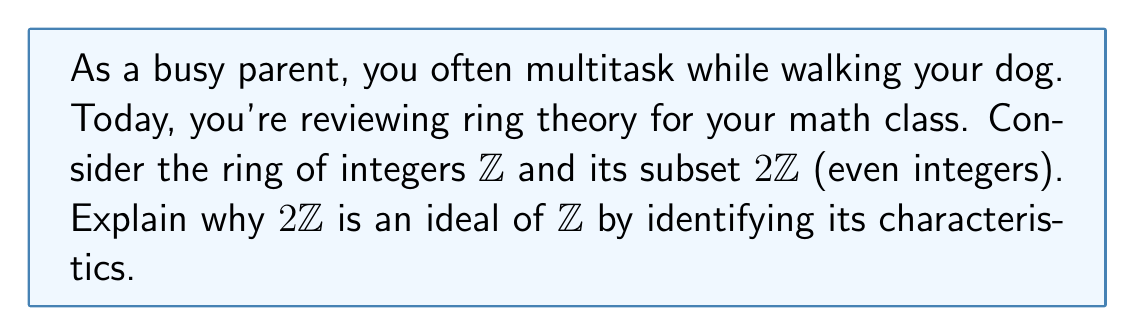Give your solution to this math problem. Let's break this down step-by-step:

1) First, recall the definition of an ideal. For a ring $R$, a subset $I$ is an ideal if:
   a) $(I, +)$ is a subgroup of $(R, +)$
   b) For all $r \in R$ and $i \in I$, both $ri \in I$ and $ir \in I$

2) Let's check if $2\mathbb{Z}$ satisfies these conditions in $\mathbb{Z}$:

   a) Is $(2\mathbb{Z}, +)$ a subgroup of $(\mathbb{Z}, +)$?
      - Closure: $2a + 2b = 2(a+b) \in 2\mathbb{Z}$ for any $a,b \in \mathbb{Z}$
      - Identity: $0 = 2(0) \in 2\mathbb{Z}$
      - Inverse: For any $2a \in 2\mathbb{Z}$, $-2a = 2(-a) \in 2\mathbb{Z}$
      So, yes, it is a subgroup.

   b) For any $r \in \mathbb{Z}$ and $2i \in 2\mathbb{Z}$:
      $r(2i) = 2(ri) \in 2\mathbb{Z}$ and $(2i)r = 2(ir) \in 2\mathbb{Z}$

3) Therefore, $2\mathbb{Z}$ satisfies both conditions and is an ideal of $\mathbb{Z}$.

4) Key characteristics of this ideal:
   - It's closed under addition and subtraction
   - Multiplication by any integer always results in an even integer
   - It contains all multiples of 2 in $\mathbb{Z}$
Answer: $2\mathbb{Z}$ is an ideal of $\mathbb{Z}$ because it's closed under addition, contains additive inverses, and is closed under multiplication by any element of $\mathbb{Z}$. 